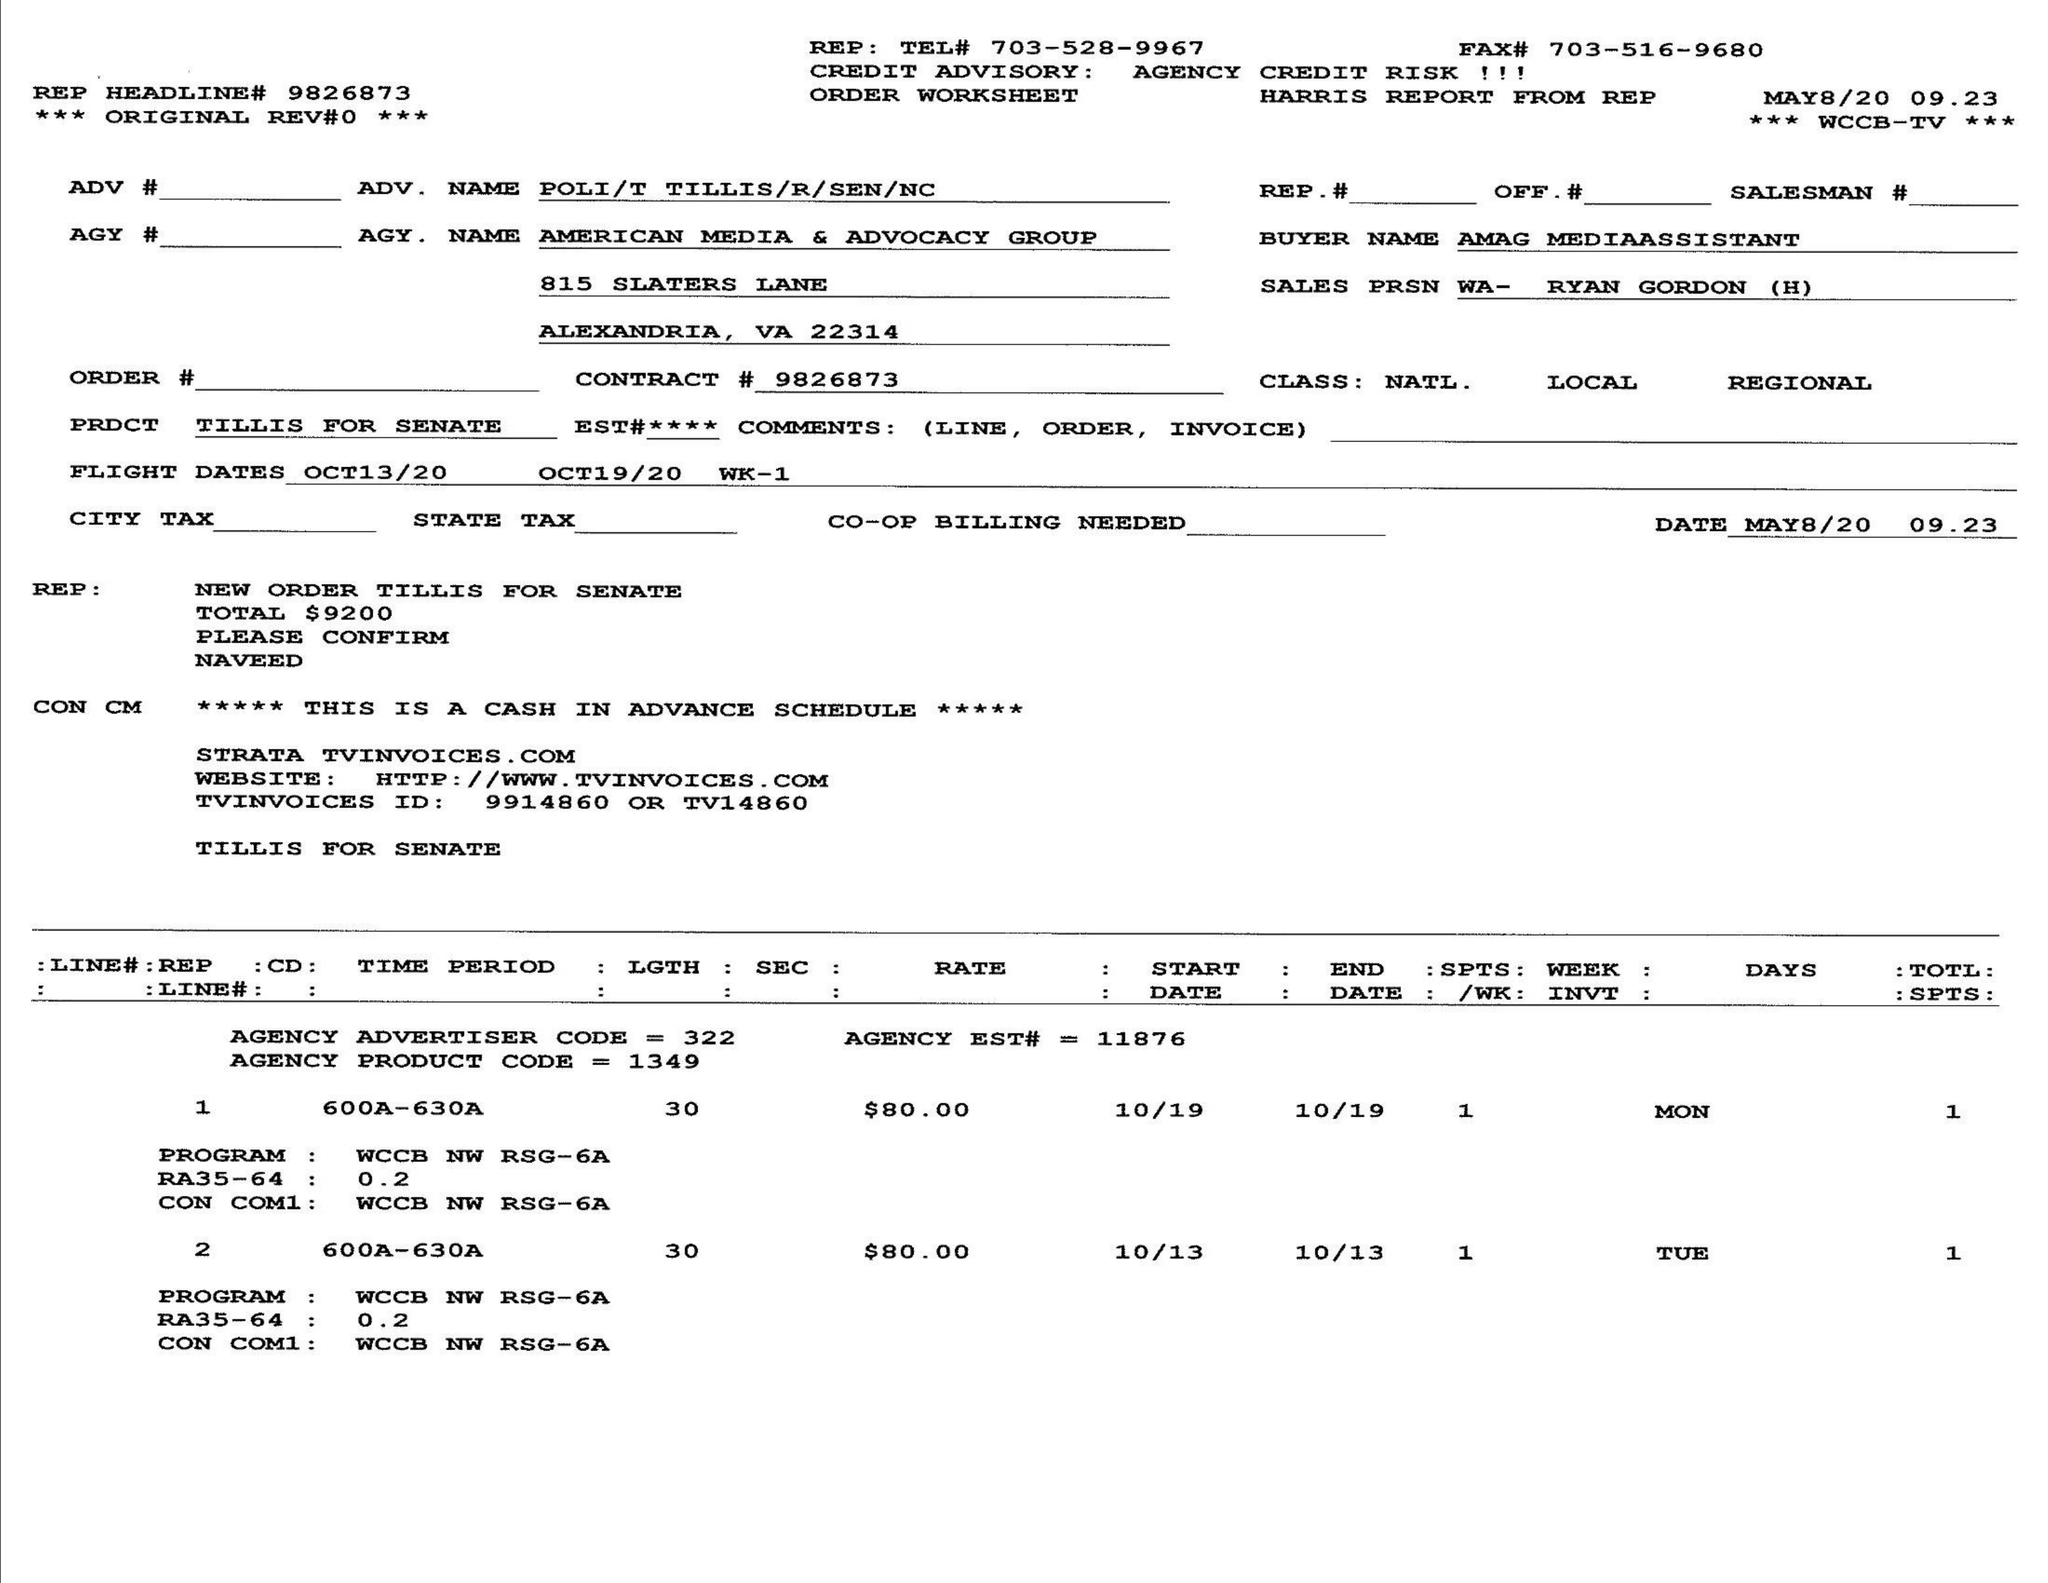What is the value for the flight_to?
Answer the question using a single word or phrase. 10/19/20 